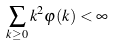<formula> <loc_0><loc_0><loc_500><loc_500>\sum _ { k \geq 0 } k ^ { 2 } \varphi ( k ) < \infty</formula> 